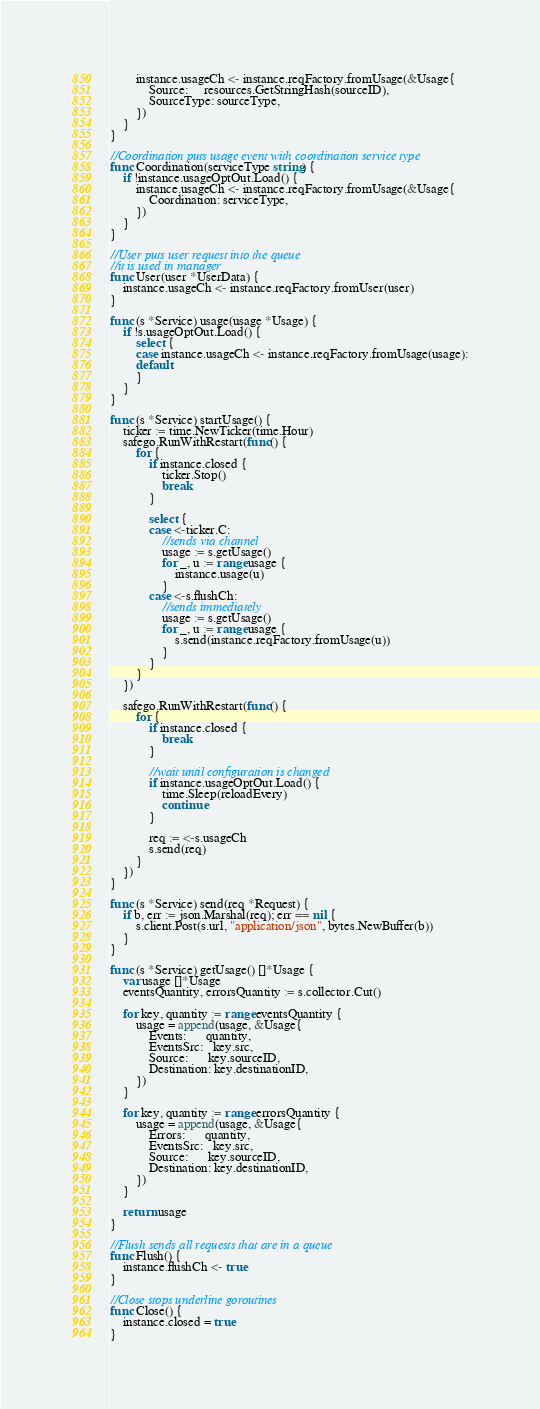Convert code to text. <code><loc_0><loc_0><loc_500><loc_500><_Go_>		instance.usageCh <- instance.reqFactory.fromUsage(&Usage{
			Source:     resources.GetStringHash(sourceID),
			SourceType: sourceType,
		})
	}
}

//Coordination puts usage event with coordination service type
func Coordination(serviceType string) {
	if !instance.usageOptOut.Load() {
		instance.usageCh <- instance.reqFactory.fromUsage(&Usage{
			Coordination: serviceType,
		})
	}
}

//User puts user request into the queue
//it is used in manager
func User(user *UserData) {
	instance.usageCh <- instance.reqFactory.fromUser(user)
}

func (s *Service) usage(usage *Usage) {
	if !s.usageOptOut.Load() {
		select {
		case instance.usageCh <- instance.reqFactory.fromUsage(usage):
		default:
		}
	}
}

func (s *Service) startUsage() {
	ticker := time.NewTicker(time.Hour)
	safego.RunWithRestart(func() {
		for {
			if instance.closed {
				ticker.Stop()
				break
			}

			select {
			case <-ticker.C:
				//sends via channel
				usage := s.getUsage()
				for _, u := range usage {
					instance.usage(u)
				}
			case <-s.flushCh:
				//sends immediately
				usage := s.getUsage()
				for _, u := range usage {
					s.send(instance.reqFactory.fromUsage(u))
				}
			}
		}
	})

	safego.RunWithRestart(func() {
		for {
			if instance.closed {
				break
			}

			//wait until configuration is changed
			if instance.usageOptOut.Load() {
				time.Sleep(reloadEvery)
				continue
			}

			req := <-s.usageCh
			s.send(req)
		}
	})
}

func (s *Service) send(req *Request) {
	if b, err := json.Marshal(req); err == nil {
		s.client.Post(s.url, "application/json", bytes.NewBuffer(b))
	}
}

func (s *Service) getUsage() []*Usage {
	var usage []*Usage
	eventsQuantity, errorsQuantity := s.collector.Cut()

	for key, quantity := range eventsQuantity {
		usage = append(usage, &Usage{
			Events:      quantity,
			EventsSrc:   key.src,
			Source:      key.sourceID,
			Destination: key.destinationID,
		})
	}

	for key, quantity := range errorsQuantity {
		usage = append(usage, &Usage{
			Errors:      quantity,
			EventsSrc:   key.src,
			Source:      key.sourceID,
			Destination: key.destinationID,
		})
	}

	return usage
}

//Flush sends all requests that are in a queue
func Flush() {
	instance.flushCh <- true
}

//Close stops underline goroutines
func Close() {
	instance.closed = true
}
</code> 